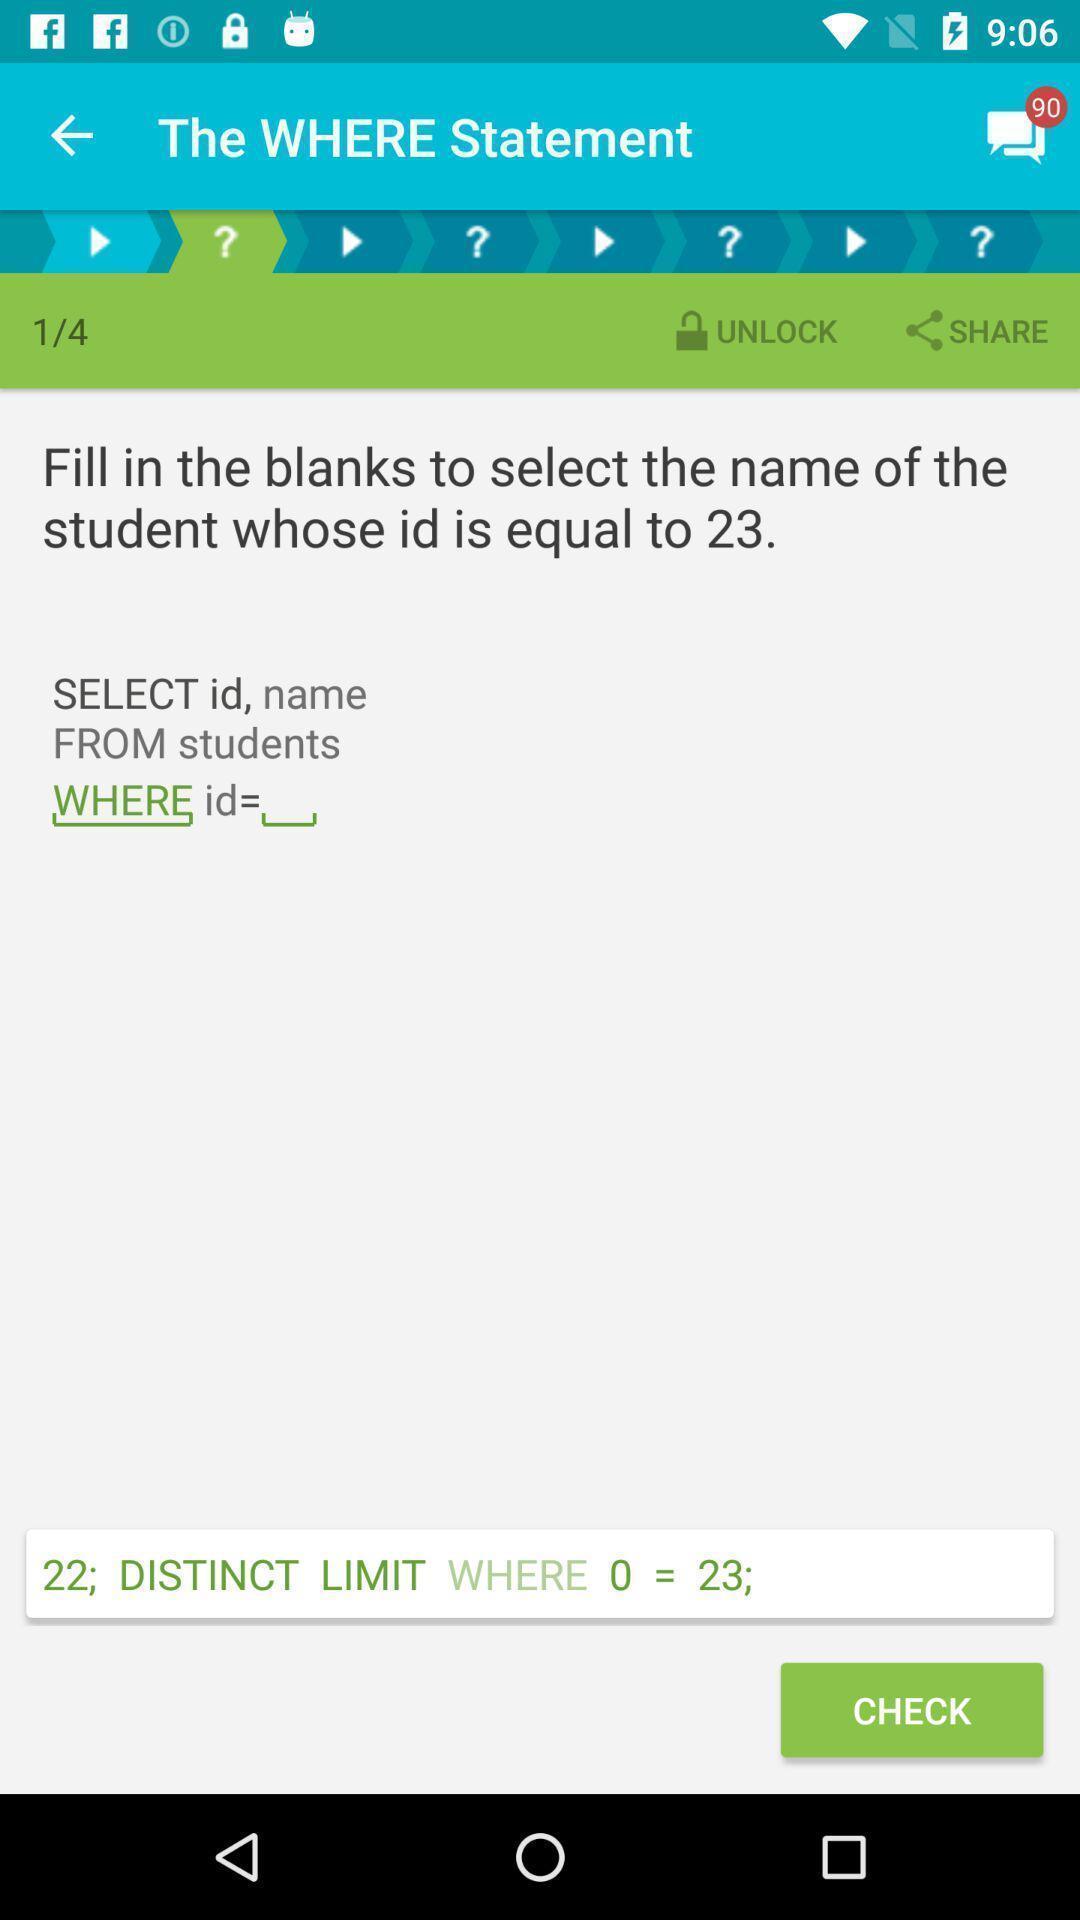Tell me about the visual elements in this screen capture. Screen shows computer language page in app. 